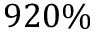Convert formula to latex. <formula><loc_0><loc_0><loc_500><loc_500>9 2 0 \%</formula> 